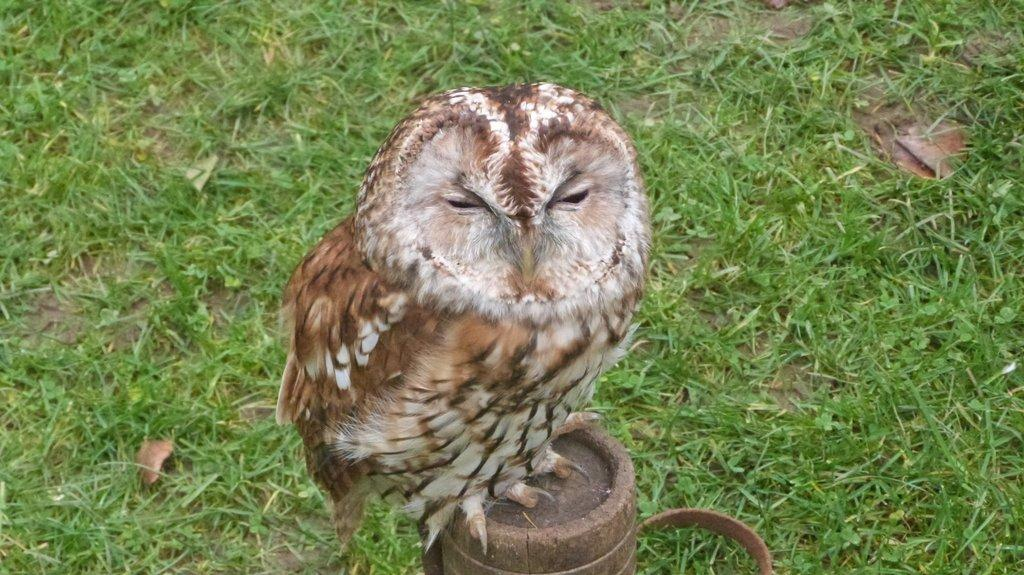What animal can be seen in the picture? There is an owl in the picture. Where is the owl sitting? The owl is sitting on a wooden stick. What type of vegetation is visible in the picture? There is grass in the picture. What can be found on the floor in the picture? Dry leaves are present on the floor. How many kittens are playing in the market in the image? There are no kittens or market present in the image; it features an owl sitting on a wooden stick with grass and dry leaves in the background. 